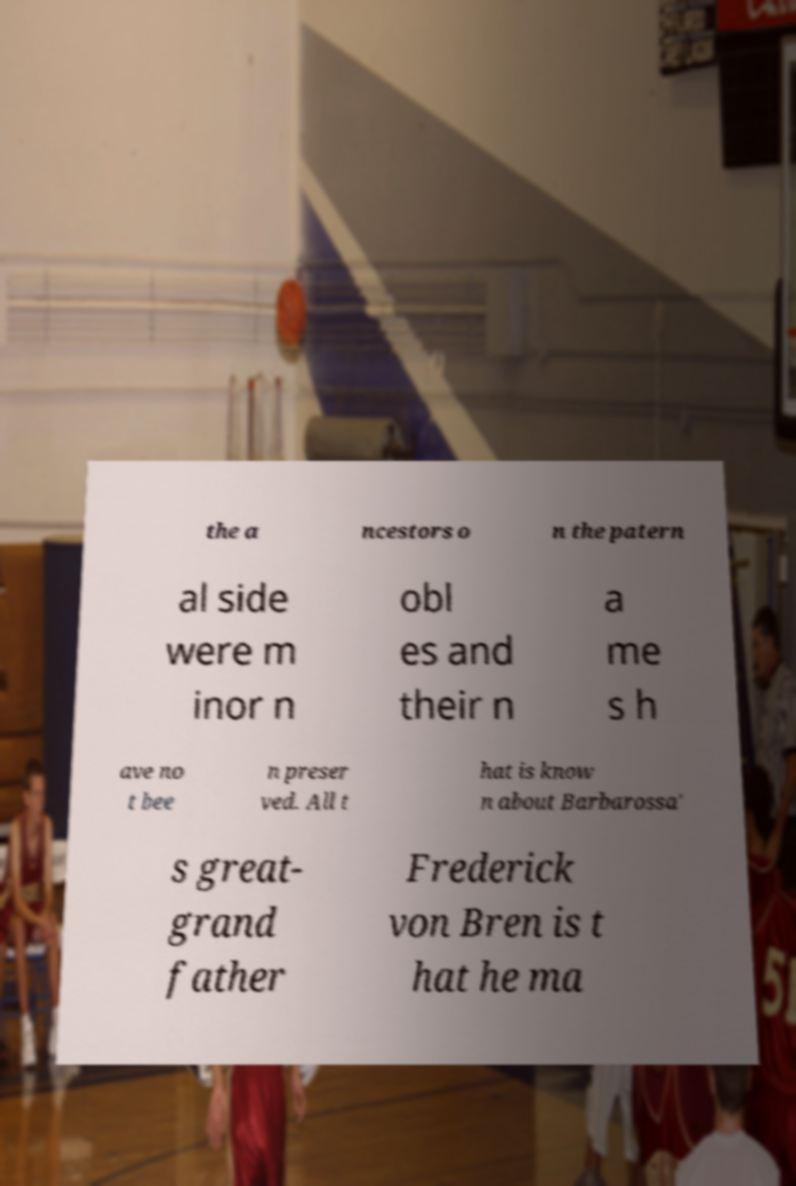Could you extract and type out the text from this image? the a ncestors o n the patern al side were m inor n obl es and their n a me s h ave no t bee n preser ved. All t hat is know n about Barbarossa' s great- grand father Frederick von Bren is t hat he ma 